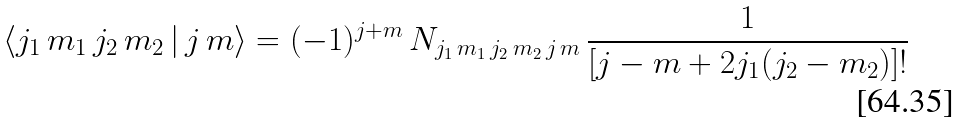<formula> <loc_0><loc_0><loc_500><loc_500>\langle j _ { 1 } \, m _ { 1 } \, j _ { 2 } \, m _ { 2 } \, | \, j \, m \rangle = ( - 1 ) ^ { j + m } \, N _ { j _ { 1 } \, m _ { 1 } \, j _ { 2 } \, m _ { 2 } \, j \, m } \, \frac { 1 } { [ j - m + 2 j _ { 1 } ( j _ { 2 } - m _ { 2 } ) ] ! }</formula> 